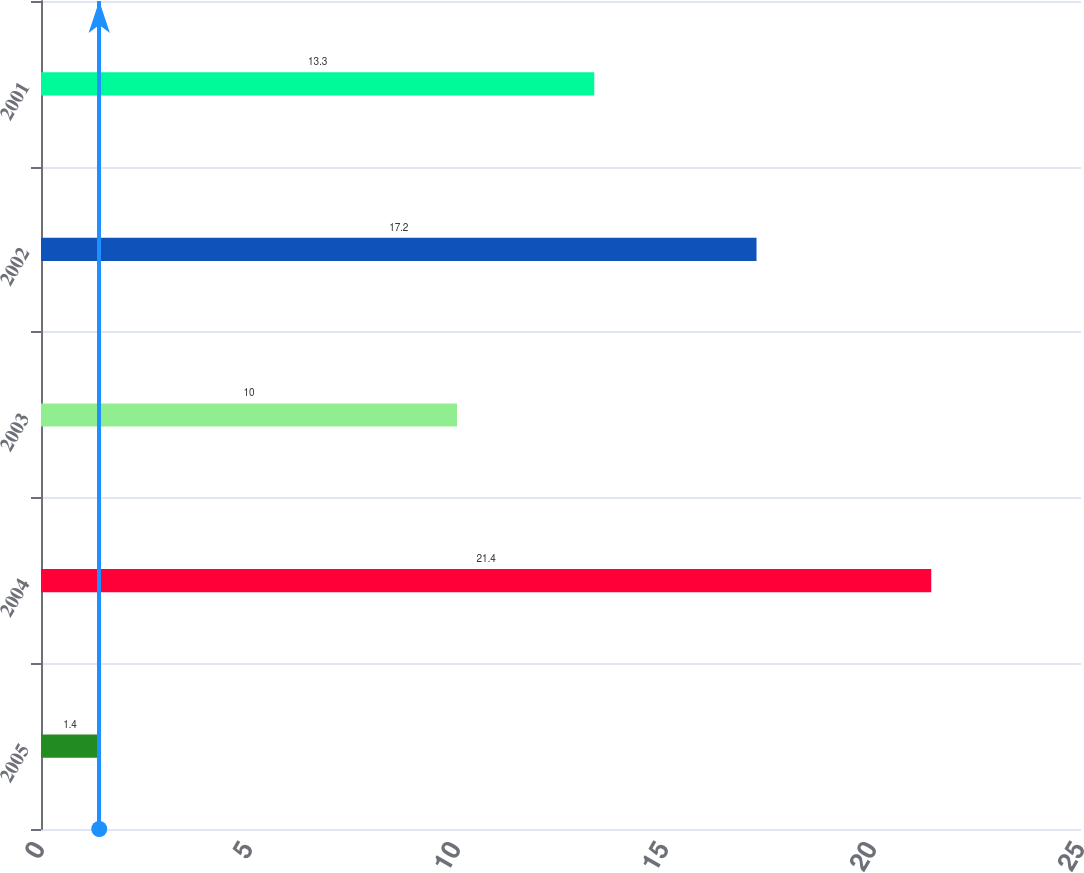Convert chart. <chart><loc_0><loc_0><loc_500><loc_500><bar_chart><fcel>2005<fcel>2004<fcel>2003<fcel>2002<fcel>2001<nl><fcel>1.4<fcel>21.4<fcel>10<fcel>17.2<fcel>13.3<nl></chart> 